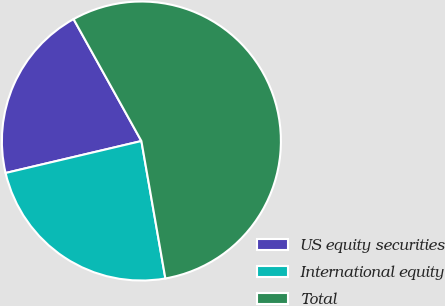Convert chart to OTSL. <chart><loc_0><loc_0><loc_500><loc_500><pie_chart><fcel>US equity securities<fcel>International equity<fcel>Total<nl><fcel>20.6%<fcel>24.07%<fcel>55.33%<nl></chart> 